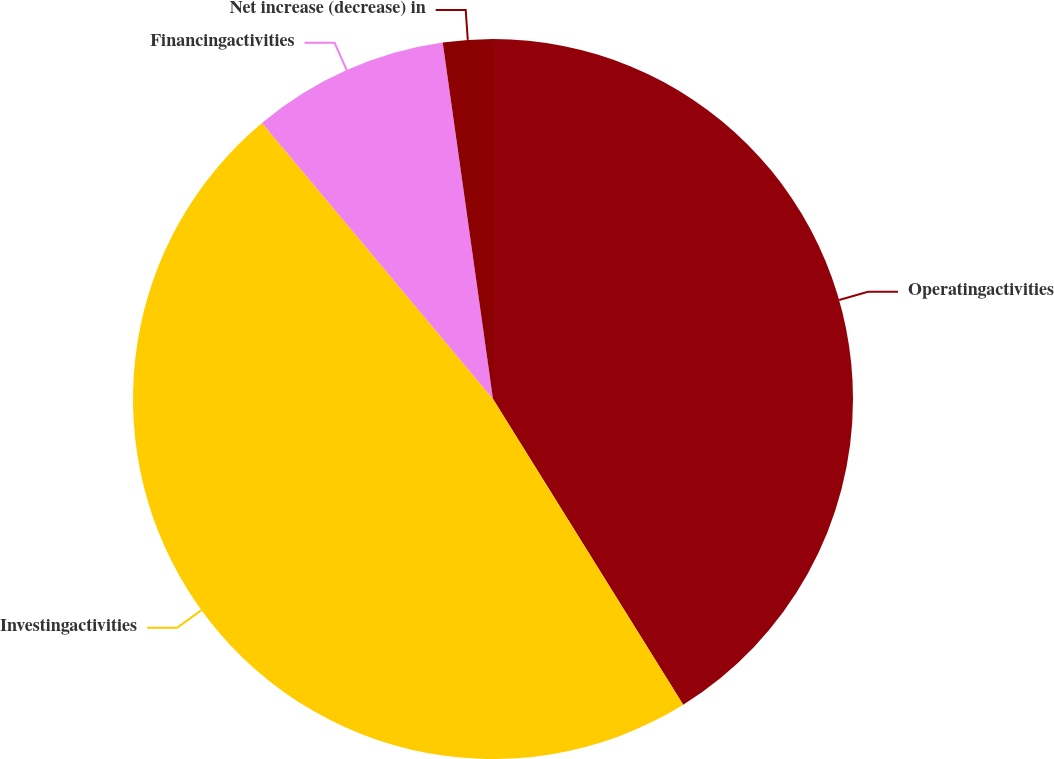Convert chart to OTSL. <chart><loc_0><loc_0><loc_500><loc_500><pie_chart><fcel>Operatingactivities<fcel>Investingactivities<fcel>Financingactivities<fcel>Net increase (decrease) in<nl><fcel>41.14%<fcel>47.77%<fcel>8.86%<fcel>2.23%<nl></chart> 